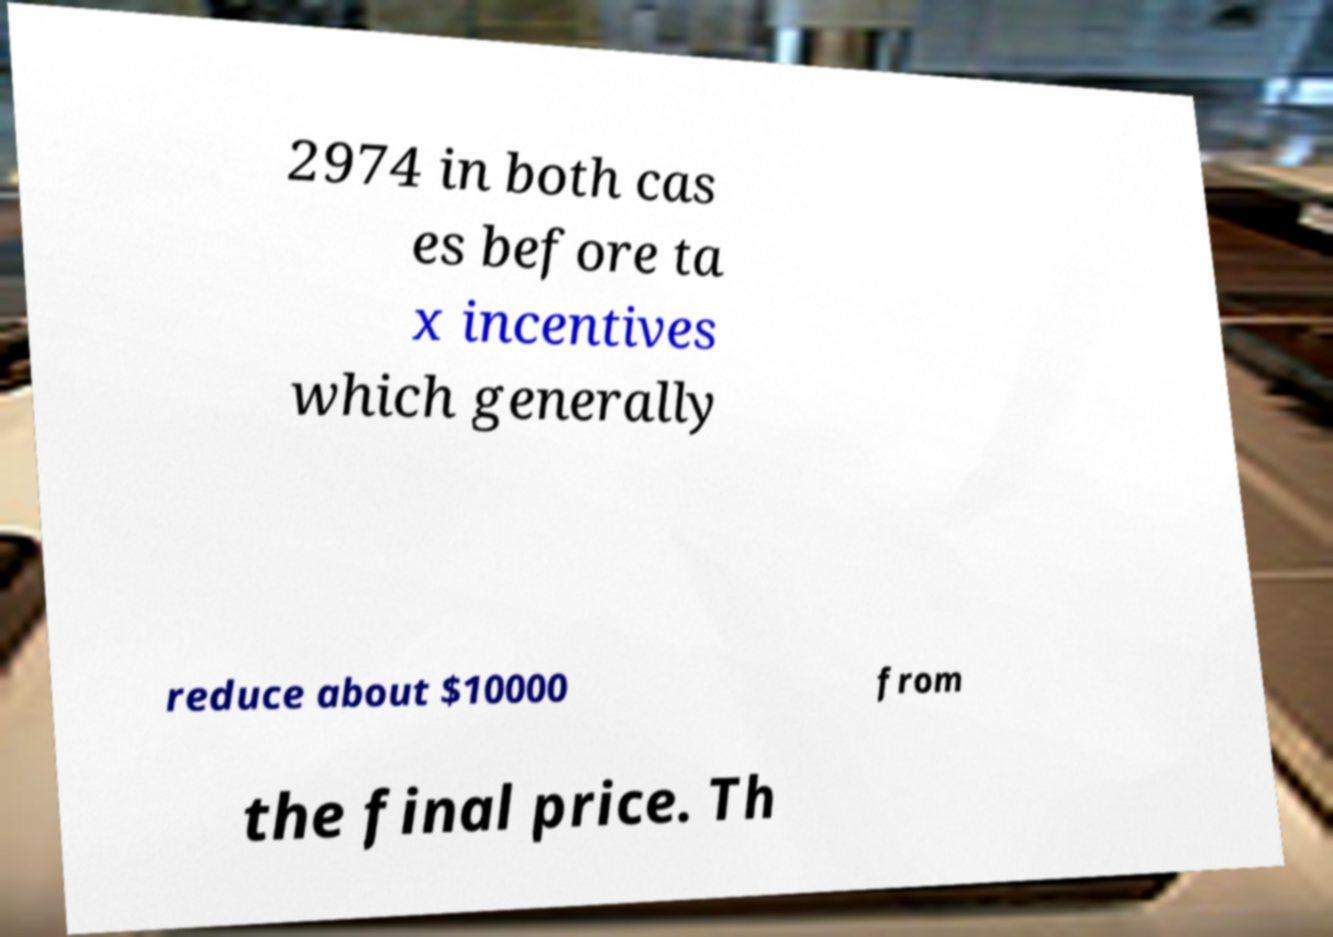Could you extract and type out the text from this image? 2974 in both cas es before ta x incentives which generally reduce about $10000 from the final price. Th 